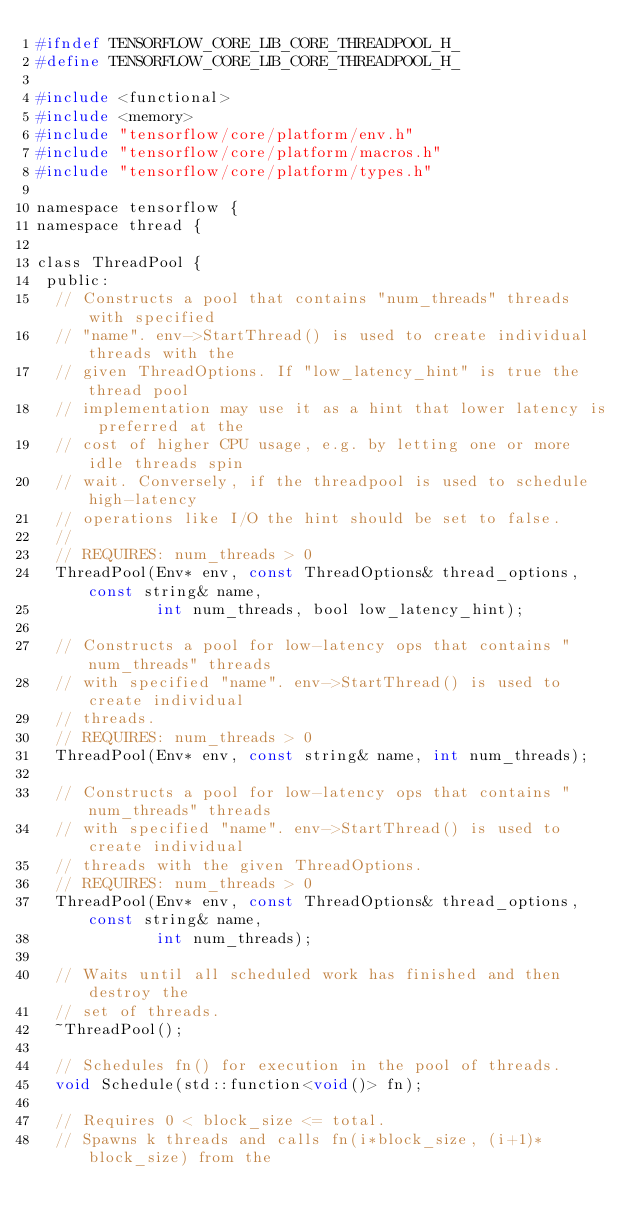<code> <loc_0><loc_0><loc_500><loc_500><_C_>#ifndef TENSORFLOW_CORE_LIB_CORE_THREADPOOL_H_
#define TENSORFLOW_CORE_LIB_CORE_THREADPOOL_H_

#include <functional>
#include <memory>
#include "tensorflow/core/platform/env.h"
#include "tensorflow/core/platform/macros.h"
#include "tensorflow/core/platform/types.h"

namespace tensorflow {
namespace thread {

class ThreadPool {
 public:
  // Constructs a pool that contains "num_threads" threads with specified
  // "name". env->StartThread() is used to create individual threads with the
  // given ThreadOptions. If "low_latency_hint" is true the thread pool
  // implementation may use it as a hint that lower latency is preferred at the
  // cost of higher CPU usage, e.g. by letting one or more idle threads spin
  // wait. Conversely, if the threadpool is used to schedule high-latency
  // operations like I/O the hint should be set to false.
  //
  // REQUIRES: num_threads > 0
  ThreadPool(Env* env, const ThreadOptions& thread_options, const string& name,
             int num_threads, bool low_latency_hint);

  // Constructs a pool for low-latency ops that contains "num_threads" threads
  // with specified "name". env->StartThread() is used to create individual
  // threads.
  // REQUIRES: num_threads > 0
  ThreadPool(Env* env, const string& name, int num_threads);

  // Constructs a pool for low-latency ops that contains "num_threads" threads
  // with specified "name". env->StartThread() is used to create individual
  // threads with the given ThreadOptions.
  // REQUIRES: num_threads > 0
  ThreadPool(Env* env, const ThreadOptions& thread_options, const string& name,
             int num_threads);

  // Waits until all scheduled work has finished and then destroy the
  // set of threads.
  ~ThreadPool();

  // Schedules fn() for execution in the pool of threads.
  void Schedule(std::function<void()> fn);

  // Requires 0 < block_size <= total.
  // Spawns k threads and calls fn(i*block_size, (i+1)*block_size) from the</code> 